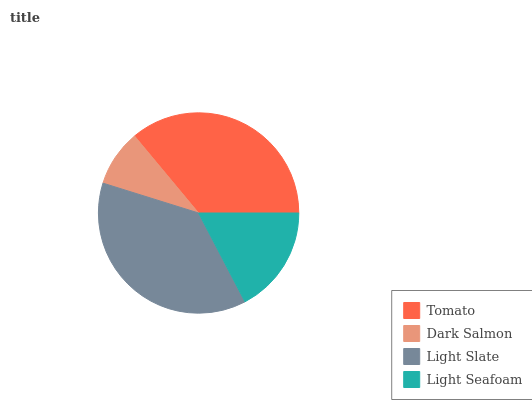Is Dark Salmon the minimum?
Answer yes or no. Yes. Is Light Slate the maximum?
Answer yes or no. Yes. Is Light Slate the minimum?
Answer yes or no. No. Is Dark Salmon the maximum?
Answer yes or no. No. Is Light Slate greater than Dark Salmon?
Answer yes or no. Yes. Is Dark Salmon less than Light Slate?
Answer yes or no. Yes. Is Dark Salmon greater than Light Slate?
Answer yes or no. No. Is Light Slate less than Dark Salmon?
Answer yes or no. No. Is Tomato the high median?
Answer yes or no. Yes. Is Light Seafoam the low median?
Answer yes or no. Yes. Is Dark Salmon the high median?
Answer yes or no. No. Is Dark Salmon the low median?
Answer yes or no. No. 